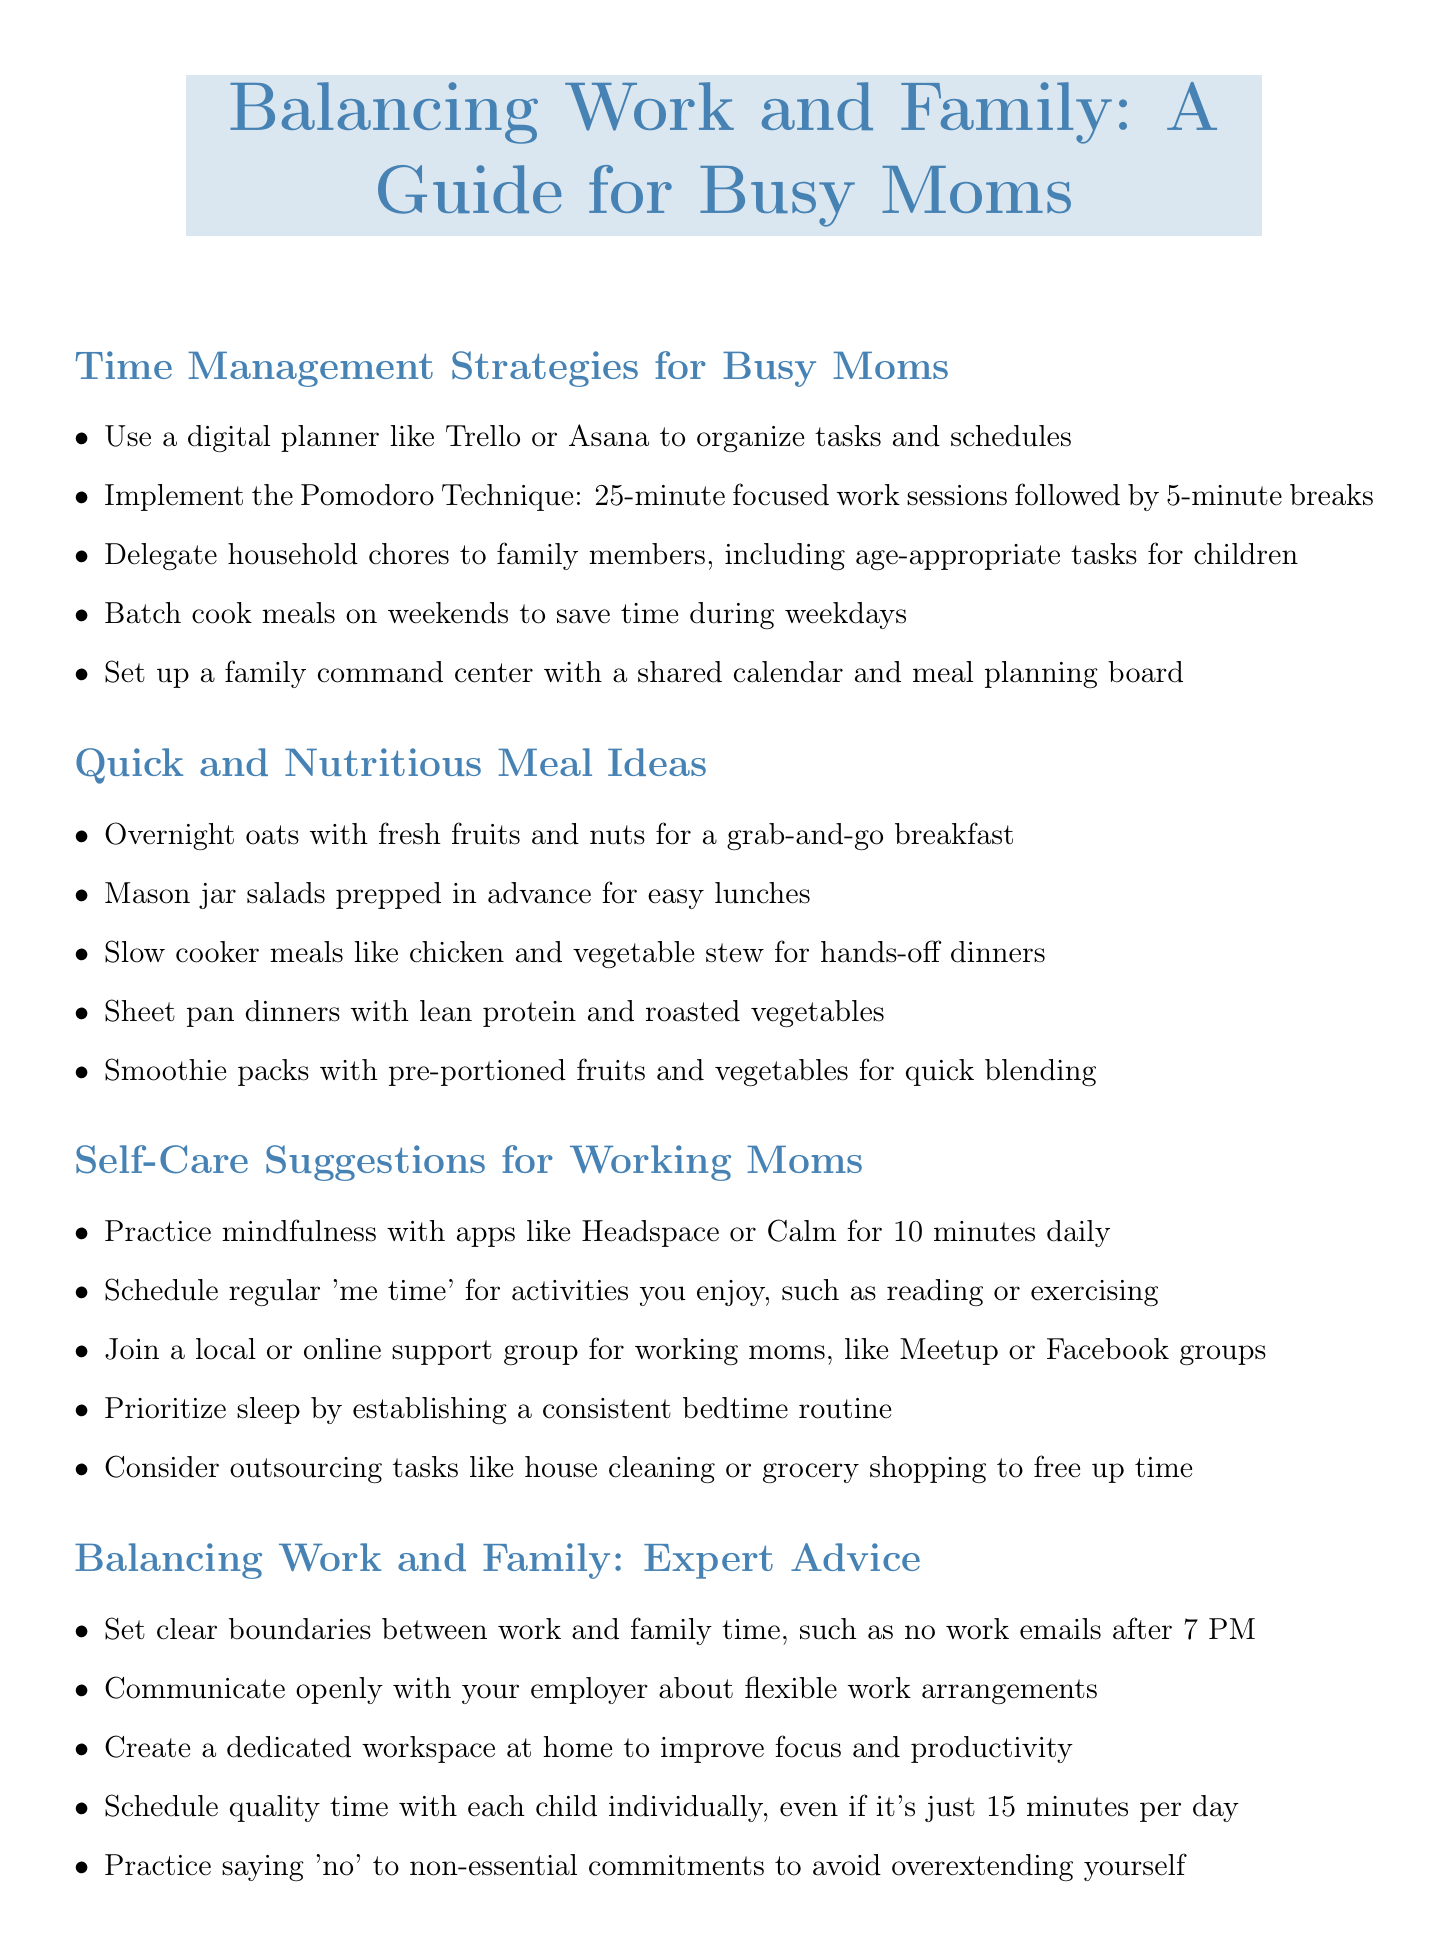What is a recommended tool for organizing tasks? The document suggests using digital planners like Trello or Asana for organizing tasks and schedules.
Answer: Trello or Asana How long are the focused work sessions in the Pomodoro Technique? The Pomodoro Technique recommends 25-minute focused work sessions followed by breaks.
Answer: 25 minutes What type of meals should be prepped in advance for easy lunches? The document mentions mason jar salads as a convenient meal prep option for lunches.
Answer: Mason jar salads What is one self-care activity suggested for busy moms? One suggested self-care activity includes practicing mindfulness with apps like Headspace or Calm.
Answer: Mindfulness What should be established for a consistent bedtime routine? The document advises prioritizing sleep by establishing a bedtime routine.
Answer: Bedtime routine What is one way to save time on shopping? The document suggests using grocery delivery apps like Instacart or Amazon Fresh to save time on shopping.
Answer: Grocery delivery apps How can moms manage finances more efficiently? The document recommends using budgeting apps like Mint or YNAB for efficient finance management.
Answer: Mint or YNAB What is an essential boundary to set between work and family? The document suggests no work emails after 7 PM as a clear boundary to set.
Answer: No work emails after 7 PM What type of workspace should be created at home? A dedicated workspace at home is recommended for improved focus and productivity.
Answer: Dedicated workspace 